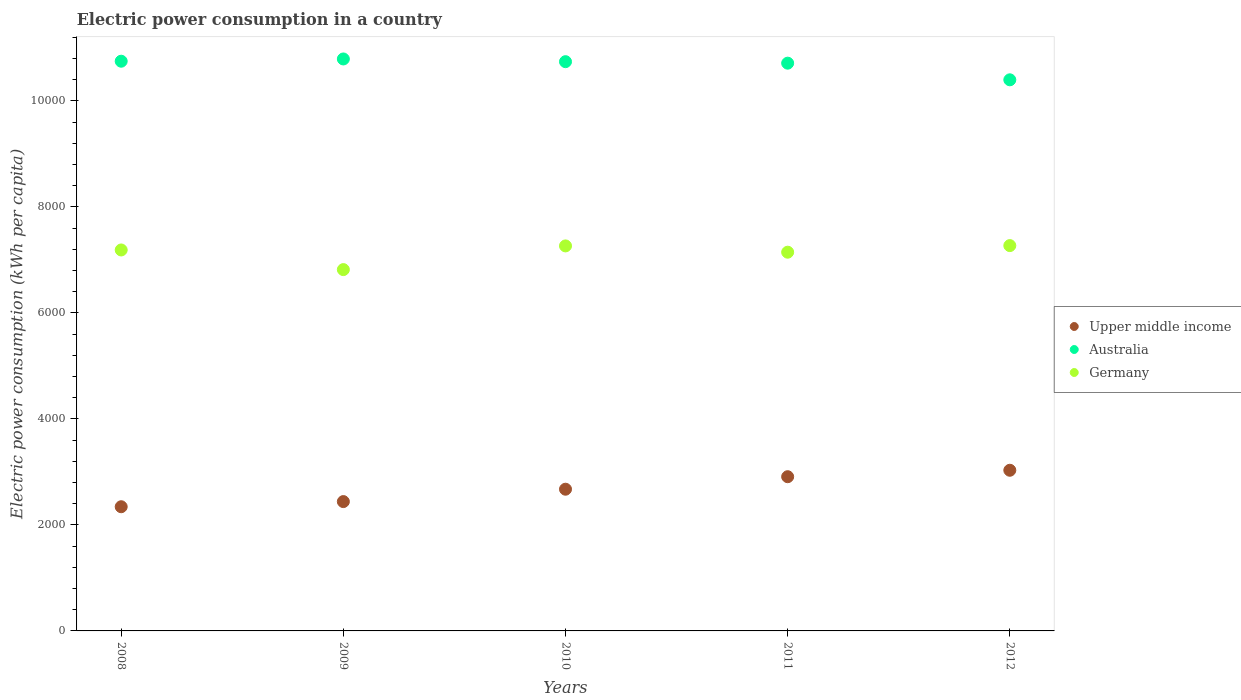How many different coloured dotlines are there?
Offer a terse response. 3. Is the number of dotlines equal to the number of legend labels?
Your answer should be very brief. Yes. What is the electric power consumption in in Germany in 2009?
Your answer should be compact. 6817.16. Across all years, what is the maximum electric power consumption in in Australia?
Provide a succinct answer. 1.08e+04. Across all years, what is the minimum electric power consumption in in Australia?
Make the answer very short. 1.04e+04. What is the total electric power consumption in in Upper middle income in the graph?
Ensure brevity in your answer.  1.34e+04. What is the difference between the electric power consumption in in Upper middle income in 2009 and that in 2011?
Offer a terse response. -469.38. What is the difference between the electric power consumption in in Upper middle income in 2008 and the electric power consumption in in Germany in 2009?
Keep it short and to the point. -4474.06. What is the average electric power consumption in in Upper middle income per year?
Ensure brevity in your answer.  2679.59. In the year 2009, what is the difference between the electric power consumption in in Australia and electric power consumption in in Germany?
Ensure brevity in your answer.  3974.39. In how many years, is the electric power consumption in in Germany greater than 5600 kWh per capita?
Ensure brevity in your answer.  5. What is the ratio of the electric power consumption in in Germany in 2011 to that in 2012?
Make the answer very short. 0.98. Is the difference between the electric power consumption in in Australia in 2008 and 2010 greater than the difference between the electric power consumption in in Germany in 2008 and 2010?
Your answer should be very brief. Yes. What is the difference between the highest and the second highest electric power consumption in in Germany?
Make the answer very short. 5.83. What is the difference between the highest and the lowest electric power consumption in in Australia?
Offer a very short reply. 393.34. Does the electric power consumption in in Upper middle income monotonically increase over the years?
Keep it short and to the point. Yes. Is the electric power consumption in in Germany strictly less than the electric power consumption in in Upper middle income over the years?
Give a very brief answer. No. How many dotlines are there?
Keep it short and to the point. 3. How many years are there in the graph?
Your answer should be very brief. 5. Where does the legend appear in the graph?
Offer a very short reply. Center right. What is the title of the graph?
Provide a succinct answer. Electric power consumption in a country. Does "Benin" appear as one of the legend labels in the graph?
Offer a very short reply. No. What is the label or title of the X-axis?
Provide a short and direct response. Years. What is the label or title of the Y-axis?
Your response must be concise. Electric power consumption (kWh per capita). What is the Electric power consumption (kWh per capita) of Upper middle income in 2008?
Ensure brevity in your answer.  2343.1. What is the Electric power consumption (kWh per capita) in Australia in 2008?
Ensure brevity in your answer.  1.07e+04. What is the Electric power consumption (kWh per capita) of Germany in 2008?
Keep it short and to the point. 7187.76. What is the Electric power consumption (kWh per capita) in Upper middle income in 2009?
Your answer should be very brief. 2440.23. What is the Electric power consumption (kWh per capita) of Australia in 2009?
Ensure brevity in your answer.  1.08e+04. What is the Electric power consumption (kWh per capita) in Germany in 2009?
Keep it short and to the point. 6817.16. What is the Electric power consumption (kWh per capita) in Upper middle income in 2010?
Offer a terse response. 2673.76. What is the Electric power consumption (kWh per capita) in Australia in 2010?
Provide a succinct answer. 1.07e+04. What is the Electric power consumption (kWh per capita) in Germany in 2010?
Provide a succinct answer. 7264.32. What is the Electric power consumption (kWh per capita) in Upper middle income in 2011?
Ensure brevity in your answer.  2909.61. What is the Electric power consumption (kWh per capita) in Australia in 2011?
Provide a short and direct response. 1.07e+04. What is the Electric power consumption (kWh per capita) of Germany in 2011?
Make the answer very short. 7145.73. What is the Electric power consumption (kWh per capita) of Upper middle income in 2012?
Provide a succinct answer. 3031.25. What is the Electric power consumption (kWh per capita) of Australia in 2012?
Make the answer very short. 1.04e+04. What is the Electric power consumption (kWh per capita) in Germany in 2012?
Give a very brief answer. 7270.15. Across all years, what is the maximum Electric power consumption (kWh per capita) in Upper middle income?
Offer a very short reply. 3031.25. Across all years, what is the maximum Electric power consumption (kWh per capita) of Australia?
Offer a terse response. 1.08e+04. Across all years, what is the maximum Electric power consumption (kWh per capita) in Germany?
Give a very brief answer. 7270.15. Across all years, what is the minimum Electric power consumption (kWh per capita) of Upper middle income?
Make the answer very short. 2343.1. Across all years, what is the minimum Electric power consumption (kWh per capita) in Australia?
Make the answer very short. 1.04e+04. Across all years, what is the minimum Electric power consumption (kWh per capita) in Germany?
Ensure brevity in your answer.  6817.16. What is the total Electric power consumption (kWh per capita) of Upper middle income in the graph?
Your answer should be compact. 1.34e+04. What is the total Electric power consumption (kWh per capita) of Australia in the graph?
Keep it short and to the point. 5.34e+04. What is the total Electric power consumption (kWh per capita) of Germany in the graph?
Offer a terse response. 3.57e+04. What is the difference between the Electric power consumption (kWh per capita) of Upper middle income in 2008 and that in 2009?
Provide a succinct answer. -97.13. What is the difference between the Electric power consumption (kWh per capita) in Australia in 2008 and that in 2009?
Provide a succinct answer. -42.48. What is the difference between the Electric power consumption (kWh per capita) of Germany in 2008 and that in 2009?
Provide a short and direct response. 370.61. What is the difference between the Electric power consumption (kWh per capita) in Upper middle income in 2008 and that in 2010?
Give a very brief answer. -330.66. What is the difference between the Electric power consumption (kWh per capita) in Australia in 2008 and that in 2010?
Provide a short and direct response. 8.65. What is the difference between the Electric power consumption (kWh per capita) of Germany in 2008 and that in 2010?
Your answer should be very brief. -76.56. What is the difference between the Electric power consumption (kWh per capita) of Upper middle income in 2008 and that in 2011?
Provide a short and direct response. -566.51. What is the difference between the Electric power consumption (kWh per capita) in Australia in 2008 and that in 2011?
Ensure brevity in your answer.  36.9. What is the difference between the Electric power consumption (kWh per capita) of Germany in 2008 and that in 2011?
Provide a succinct answer. 42.04. What is the difference between the Electric power consumption (kWh per capita) of Upper middle income in 2008 and that in 2012?
Offer a very short reply. -688.15. What is the difference between the Electric power consumption (kWh per capita) of Australia in 2008 and that in 2012?
Offer a terse response. 350.86. What is the difference between the Electric power consumption (kWh per capita) of Germany in 2008 and that in 2012?
Your response must be concise. -82.39. What is the difference between the Electric power consumption (kWh per capita) in Upper middle income in 2009 and that in 2010?
Ensure brevity in your answer.  -233.54. What is the difference between the Electric power consumption (kWh per capita) in Australia in 2009 and that in 2010?
Offer a very short reply. 51.14. What is the difference between the Electric power consumption (kWh per capita) of Germany in 2009 and that in 2010?
Make the answer very short. -447.16. What is the difference between the Electric power consumption (kWh per capita) of Upper middle income in 2009 and that in 2011?
Offer a very short reply. -469.38. What is the difference between the Electric power consumption (kWh per capita) of Australia in 2009 and that in 2011?
Offer a very short reply. 79.38. What is the difference between the Electric power consumption (kWh per capita) of Germany in 2009 and that in 2011?
Your answer should be very brief. -328.57. What is the difference between the Electric power consumption (kWh per capita) of Upper middle income in 2009 and that in 2012?
Provide a short and direct response. -591.02. What is the difference between the Electric power consumption (kWh per capita) of Australia in 2009 and that in 2012?
Your answer should be compact. 393.34. What is the difference between the Electric power consumption (kWh per capita) of Germany in 2009 and that in 2012?
Give a very brief answer. -452.99. What is the difference between the Electric power consumption (kWh per capita) of Upper middle income in 2010 and that in 2011?
Give a very brief answer. -235.85. What is the difference between the Electric power consumption (kWh per capita) of Australia in 2010 and that in 2011?
Provide a succinct answer. 28.24. What is the difference between the Electric power consumption (kWh per capita) in Germany in 2010 and that in 2011?
Give a very brief answer. 118.59. What is the difference between the Electric power consumption (kWh per capita) of Upper middle income in 2010 and that in 2012?
Make the answer very short. -357.48. What is the difference between the Electric power consumption (kWh per capita) of Australia in 2010 and that in 2012?
Keep it short and to the point. 342.21. What is the difference between the Electric power consumption (kWh per capita) of Germany in 2010 and that in 2012?
Provide a succinct answer. -5.83. What is the difference between the Electric power consumption (kWh per capita) of Upper middle income in 2011 and that in 2012?
Make the answer very short. -121.64. What is the difference between the Electric power consumption (kWh per capita) of Australia in 2011 and that in 2012?
Keep it short and to the point. 313.96. What is the difference between the Electric power consumption (kWh per capita) in Germany in 2011 and that in 2012?
Offer a very short reply. -124.42. What is the difference between the Electric power consumption (kWh per capita) in Upper middle income in 2008 and the Electric power consumption (kWh per capita) in Australia in 2009?
Offer a very short reply. -8448.45. What is the difference between the Electric power consumption (kWh per capita) of Upper middle income in 2008 and the Electric power consumption (kWh per capita) of Germany in 2009?
Give a very brief answer. -4474.06. What is the difference between the Electric power consumption (kWh per capita) in Australia in 2008 and the Electric power consumption (kWh per capita) in Germany in 2009?
Provide a short and direct response. 3931.91. What is the difference between the Electric power consumption (kWh per capita) in Upper middle income in 2008 and the Electric power consumption (kWh per capita) in Australia in 2010?
Your answer should be compact. -8397.31. What is the difference between the Electric power consumption (kWh per capita) of Upper middle income in 2008 and the Electric power consumption (kWh per capita) of Germany in 2010?
Your answer should be compact. -4921.22. What is the difference between the Electric power consumption (kWh per capita) in Australia in 2008 and the Electric power consumption (kWh per capita) in Germany in 2010?
Ensure brevity in your answer.  3484.74. What is the difference between the Electric power consumption (kWh per capita) in Upper middle income in 2008 and the Electric power consumption (kWh per capita) in Australia in 2011?
Give a very brief answer. -8369.06. What is the difference between the Electric power consumption (kWh per capita) in Upper middle income in 2008 and the Electric power consumption (kWh per capita) in Germany in 2011?
Offer a very short reply. -4802.63. What is the difference between the Electric power consumption (kWh per capita) of Australia in 2008 and the Electric power consumption (kWh per capita) of Germany in 2011?
Keep it short and to the point. 3603.33. What is the difference between the Electric power consumption (kWh per capita) of Upper middle income in 2008 and the Electric power consumption (kWh per capita) of Australia in 2012?
Offer a very short reply. -8055.1. What is the difference between the Electric power consumption (kWh per capita) in Upper middle income in 2008 and the Electric power consumption (kWh per capita) in Germany in 2012?
Provide a succinct answer. -4927.05. What is the difference between the Electric power consumption (kWh per capita) in Australia in 2008 and the Electric power consumption (kWh per capita) in Germany in 2012?
Your answer should be very brief. 3478.91. What is the difference between the Electric power consumption (kWh per capita) of Upper middle income in 2009 and the Electric power consumption (kWh per capita) of Australia in 2010?
Your answer should be very brief. -8300.18. What is the difference between the Electric power consumption (kWh per capita) of Upper middle income in 2009 and the Electric power consumption (kWh per capita) of Germany in 2010?
Offer a very short reply. -4824.09. What is the difference between the Electric power consumption (kWh per capita) in Australia in 2009 and the Electric power consumption (kWh per capita) in Germany in 2010?
Make the answer very short. 3527.22. What is the difference between the Electric power consumption (kWh per capita) of Upper middle income in 2009 and the Electric power consumption (kWh per capita) of Australia in 2011?
Ensure brevity in your answer.  -8271.94. What is the difference between the Electric power consumption (kWh per capita) in Upper middle income in 2009 and the Electric power consumption (kWh per capita) in Germany in 2011?
Give a very brief answer. -4705.5. What is the difference between the Electric power consumption (kWh per capita) in Australia in 2009 and the Electric power consumption (kWh per capita) in Germany in 2011?
Your answer should be compact. 3645.82. What is the difference between the Electric power consumption (kWh per capita) in Upper middle income in 2009 and the Electric power consumption (kWh per capita) in Australia in 2012?
Your answer should be very brief. -7957.98. What is the difference between the Electric power consumption (kWh per capita) in Upper middle income in 2009 and the Electric power consumption (kWh per capita) in Germany in 2012?
Make the answer very short. -4829.92. What is the difference between the Electric power consumption (kWh per capita) in Australia in 2009 and the Electric power consumption (kWh per capita) in Germany in 2012?
Provide a succinct answer. 3521.39. What is the difference between the Electric power consumption (kWh per capita) of Upper middle income in 2010 and the Electric power consumption (kWh per capita) of Australia in 2011?
Provide a succinct answer. -8038.4. What is the difference between the Electric power consumption (kWh per capita) of Upper middle income in 2010 and the Electric power consumption (kWh per capita) of Germany in 2011?
Make the answer very short. -4471.97. What is the difference between the Electric power consumption (kWh per capita) of Australia in 2010 and the Electric power consumption (kWh per capita) of Germany in 2011?
Offer a terse response. 3594.68. What is the difference between the Electric power consumption (kWh per capita) in Upper middle income in 2010 and the Electric power consumption (kWh per capita) in Australia in 2012?
Give a very brief answer. -7724.44. What is the difference between the Electric power consumption (kWh per capita) of Upper middle income in 2010 and the Electric power consumption (kWh per capita) of Germany in 2012?
Ensure brevity in your answer.  -4596.39. What is the difference between the Electric power consumption (kWh per capita) in Australia in 2010 and the Electric power consumption (kWh per capita) in Germany in 2012?
Your response must be concise. 3470.26. What is the difference between the Electric power consumption (kWh per capita) of Upper middle income in 2011 and the Electric power consumption (kWh per capita) of Australia in 2012?
Offer a very short reply. -7488.59. What is the difference between the Electric power consumption (kWh per capita) in Upper middle income in 2011 and the Electric power consumption (kWh per capita) in Germany in 2012?
Offer a very short reply. -4360.54. What is the difference between the Electric power consumption (kWh per capita) in Australia in 2011 and the Electric power consumption (kWh per capita) in Germany in 2012?
Make the answer very short. 3442.01. What is the average Electric power consumption (kWh per capita) of Upper middle income per year?
Provide a short and direct response. 2679.59. What is the average Electric power consumption (kWh per capita) of Australia per year?
Provide a short and direct response. 1.07e+04. What is the average Electric power consumption (kWh per capita) in Germany per year?
Your response must be concise. 7137.03. In the year 2008, what is the difference between the Electric power consumption (kWh per capita) of Upper middle income and Electric power consumption (kWh per capita) of Australia?
Your answer should be compact. -8405.96. In the year 2008, what is the difference between the Electric power consumption (kWh per capita) of Upper middle income and Electric power consumption (kWh per capita) of Germany?
Give a very brief answer. -4844.66. In the year 2008, what is the difference between the Electric power consumption (kWh per capita) in Australia and Electric power consumption (kWh per capita) in Germany?
Make the answer very short. 3561.3. In the year 2009, what is the difference between the Electric power consumption (kWh per capita) of Upper middle income and Electric power consumption (kWh per capita) of Australia?
Keep it short and to the point. -8351.32. In the year 2009, what is the difference between the Electric power consumption (kWh per capita) of Upper middle income and Electric power consumption (kWh per capita) of Germany?
Your answer should be very brief. -4376.93. In the year 2009, what is the difference between the Electric power consumption (kWh per capita) of Australia and Electric power consumption (kWh per capita) of Germany?
Make the answer very short. 3974.39. In the year 2010, what is the difference between the Electric power consumption (kWh per capita) of Upper middle income and Electric power consumption (kWh per capita) of Australia?
Provide a succinct answer. -8066.64. In the year 2010, what is the difference between the Electric power consumption (kWh per capita) of Upper middle income and Electric power consumption (kWh per capita) of Germany?
Make the answer very short. -4590.56. In the year 2010, what is the difference between the Electric power consumption (kWh per capita) in Australia and Electric power consumption (kWh per capita) in Germany?
Ensure brevity in your answer.  3476.09. In the year 2011, what is the difference between the Electric power consumption (kWh per capita) of Upper middle income and Electric power consumption (kWh per capita) of Australia?
Your answer should be very brief. -7802.55. In the year 2011, what is the difference between the Electric power consumption (kWh per capita) in Upper middle income and Electric power consumption (kWh per capita) in Germany?
Your answer should be compact. -4236.12. In the year 2011, what is the difference between the Electric power consumption (kWh per capita) in Australia and Electric power consumption (kWh per capita) in Germany?
Keep it short and to the point. 3566.43. In the year 2012, what is the difference between the Electric power consumption (kWh per capita) of Upper middle income and Electric power consumption (kWh per capita) of Australia?
Your answer should be compact. -7366.95. In the year 2012, what is the difference between the Electric power consumption (kWh per capita) in Upper middle income and Electric power consumption (kWh per capita) in Germany?
Your response must be concise. -4238.9. In the year 2012, what is the difference between the Electric power consumption (kWh per capita) of Australia and Electric power consumption (kWh per capita) of Germany?
Your answer should be very brief. 3128.05. What is the ratio of the Electric power consumption (kWh per capita) in Upper middle income in 2008 to that in 2009?
Provide a short and direct response. 0.96. What is the ratio of the Electric power consumption (kWh per capita) in Germany in 2008 to that in 2009?
Keep it short and to the point. 1.05. What is the ratio of the Electric power consumption (kWh per capita) in Upper middle income in 2008 to that in 2010?
Offer a terse response. 0.88. What is the ratio of the Electric power consumption (kWh per capita) of Germany in 2008 to that in 2010?
Offer a very short reply. 0.99. What is the ratio of the Electric power consumption (kWh per capita) in Upper middle income in 2008 to that in 2011?
Provide a succinct answer. 0.81. What is the ratio of the Electric power consumption (kWh per capita) in Australia in 2008 to that in 2011?
Offer a terse response. 1. What is the ratio of the Electric power consumption (kWh per capita) of Germany in 2008 to that in 2011?
Your response must be concise. 1.01. What is the ratio of the Electric power consumption (kWh per capita) of Upper middle income in 2008 to that in 2012?
Provide a succinct answer. 0.77. What is the ratio of the Electric power consumption (kWh per capita) in Australia in 2008 to that in 2012?
Your answer should be very brief. 1.03. What is the ratio of the Electric power consumption (kWh per capita) in Germany in 2008 to that in 2012?
Ensure brevity in your answer.  0.99. What is the ratio of the Electric power consumption (kWh per capita) in Upper middle income in 2009 to that in 2010?
Make the answer very short. 0.91. What is the ratio of the Electric power consumption (kWh per capita) of Australia in 2009 to that in 2010?
Keep it short and to the point. 1. What is the ratio of the Electric power consumption (kWh per capita) in Germany in 2009 to that in 2010?
Your answer should be very brief. 0.94. What is the ratio of the Electric power consumption (kWh per capita) in Upper middle income in 2009 to that in 2011?
Ensure brevity in your answer.  0.84. What is the ratio of the Electric power consumption (kWh per capita) in Australia in 2009 to that in 2011?
Keep it short and to the point. 1.01. What is the ratio of the Electric power consumption (kWh per capita) in Germany in 2009 to that in 2011?
Keep it short and to the point. 0.95. What is the ratio of the Electric power consumption (kWh per capita) in Upper middle income in 2009 to that in 2012?
Keep it short and to the point. 0.81. What is the ratio of the Electric power consumption (kWh per capita) of Australia in 2009 to that in 2012?
Give a very brief answer. 1.04. What is the ratio of the Electric power consumption (kWh per capita) in Germany in 2009 to that in 2012?
Give a very brief answer. 0.94. What is the ratio of the Electric power consumption (kWh per capita) of Upper middle income in 2010 to that in 2011?
Give a very brief answer. 0.92. What is the ratio of the Electric power consumption (kWh per capita) in Australia in 2010 to that in 2011?
Provide a succinct answer. 1. What is the ratio of the Electric power consumption (kWh per capita) of Germany in 2010 to that in 2011?
Your response must be concise. 1.02. What is the ratio of the Electric power consumption (kWh per capita) of Upper middle income in 2010 to that in 2012?
Your answer should be very brief. 0.88. What is the ratio of the Electric power consumption (kWh per capita) of Australia in 2010 to that in 2012?
Provide a succinct answer. 1.03. What is the ratio of the Electric power consumption (kWh per capita) in Upper middle income in 2011 to that in 2012?
Ensure brevity in your answer.  0.96. What is the ratio of the Electric power consumption (kWh per capita) of Australia in 2011 to that in 2012?
Provide a succinct answer. 1.03. What is the ratio of the Electric power consumption (kWh per capita) in Germany in 2011 to that in 2012?
Keep it short and to the point. 0.98. What is the difference between the highest and the second highest Electric power consumption (kWh per capita) in Upper middle income?
Provide a short and direct response. 121.64. What is the difference between the highest and the second highest Electric power consumption (kWh per capita) in Australia?
Provide a succinct answer. 42.48. What is the difference between the highest and the second highest Electric power consumption (kWh per capita) of Germany?
Your answer should be very brief. 5.83. What is the difference between the highest and the lowest Electric power consumption (kWh per capita) of Upper middle income?
Offer a terse response. 688.15. What is the difference between the highest and the lowest Electric power consumption (kWh per capita) in Australia?
Your response must be concise. 393.34. What is the difference between the highest and the lowest Electric power consumption (kWh per capita) of Germany?
Offer a very short reply. 452.99. 